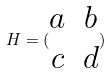<formula> <loc_0><loc_0><loc_500><loc_500>H = ( \begin{matrix} a & b \\ c & d \end{matrix} )</formula> 